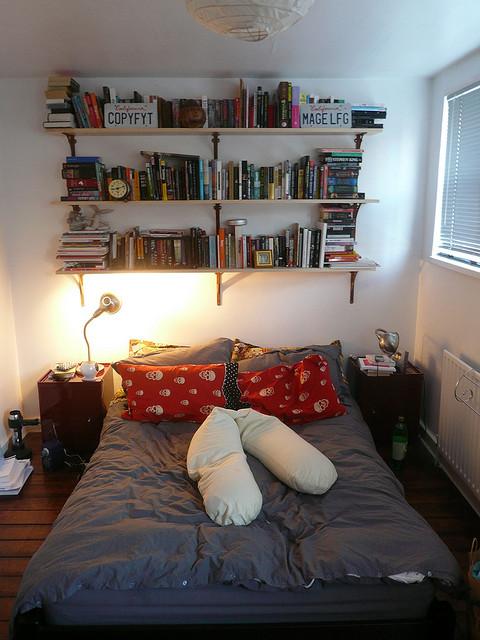Would this room be used primarily for sleeping?
Concise answer only. Yes. What room is this?
Concise answer only. Bedroom. What type of room is this?
Give a very brief answer. Bedroom. What color is the bedspread?
Be succinct. Blue. How many pillows are there?
Quick response, please. 5. How many license plates are on the shelves?
Give a very brief answer. 2. 